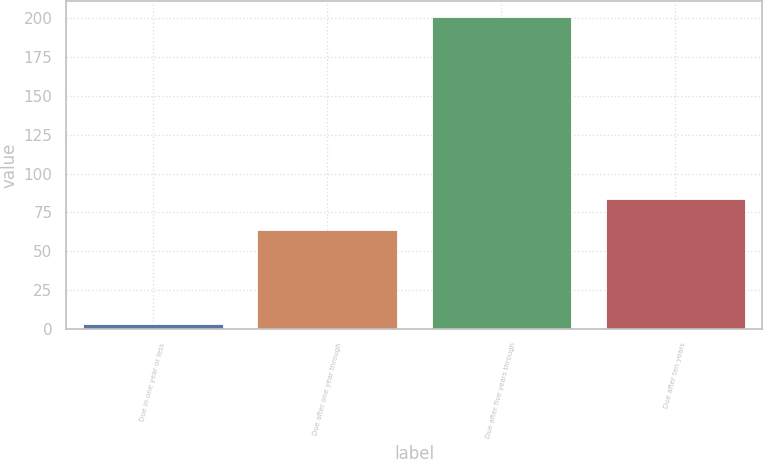Convert chart to OTSL. <chart><loc_0><loc_0><loc_500><loc_500><bar_chart><fcel>Due in one year or less<fcel>Due after one year through<fcel>Due after five years through<fcel>Due after ten years<nl><fcel>3<fcel>64<fcel>201<fcel>83.8<nl></chart> 